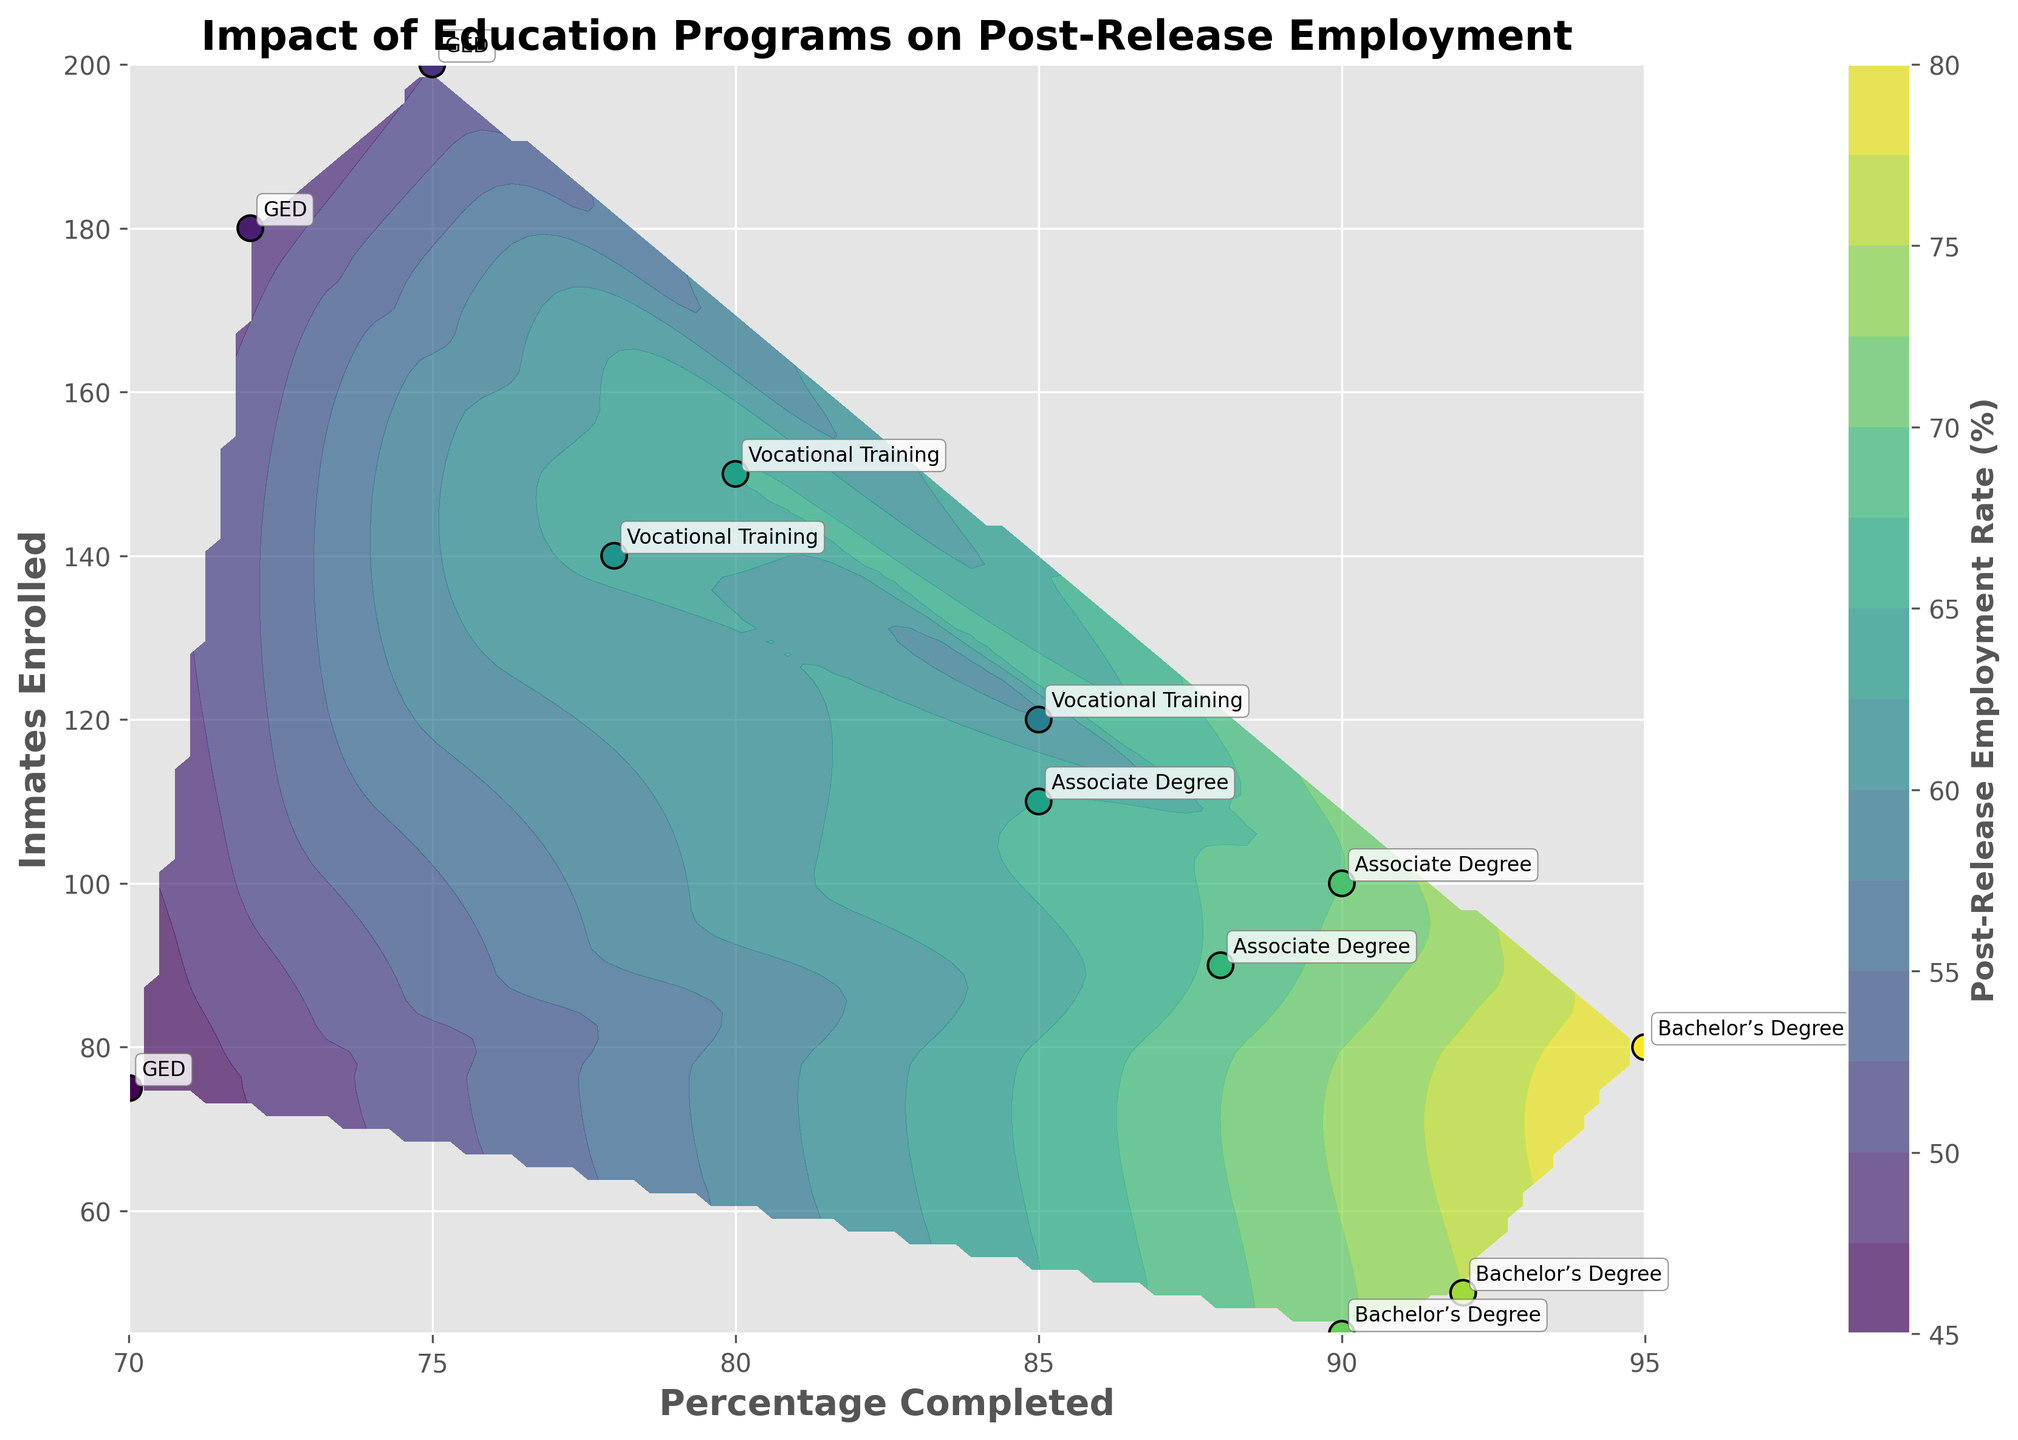What is the title of the figure? The title of the figure is usually located at the top, and it summarises the central theme of the plot. This plot's title is "Impact of Education Programs on Post-Release Employment".
Answer: Impact of Education Programs on Post-Release Employment What does the color bar represent and where is it located? The color bar is usually located beside the main plot and it indicates the magnitude of a variable. In this figure, the color bar represents the 'Post-Release Employment Rate (%)'.
Answer: Post-Release Employment Rate (%) How many inmates enrolled in the Bachelor’s Degree program at Attica Correctional Facility? Each data point on the plot is labeled with the education program. We locate the point corresponding to the Bachelor's Degree at Attica Correctional Facility on the plot and check the y-axis value for the number of inmates enrolled.
Answer: 45 Which education program had the highest post-release employment rate and at which facility? The color of the scatter points corresponds to the post-release employment rate. The darkest point (higher value) represents the highest rate. By looking at the plot, the Bachelor’s Degree at Marion Correctional Institution had the highest post-release employment rate.
Answer: Bachelor’s Degree at Marion Correctional Institution Which education program has the smallest percentage completed? By inspecting the x-axis, which indicates the 'Percentage Completed', we locate the left-most point on the plot. The GED program at Attica Correctional Facility has the smallest percentage completed.
Answer: GED at Attica Correctional Facility What is the common pattern between the completion percentage and the post-release employment rate? To discern this pattern, we observe the trend of the contour lines and scatter points. Higher percentage completions (right side of the plot) generally show higher employment rates (darker colors).
Answer: Higher completion percentages correspond to higher post-release employment rates Are there any facilities where multiple education programs are offered? If so, name them. By examining the annotations and points in the plot, we can see that some facilities have multiple programs. Folsom State Prison and Marion Correctional Institution offer multiple programs.
Answer: Folsom State Prison and Marion Correctional Institution Compare the post-release employment rate of the Vocational Training program at Folsom State Prison to the GED program at the same location. The color and value indicating post-release employment rates can be used for comparison. The Vocational Training program has a higher employment rate than the GED program at Folsom State Prison.
Answer: Vocational Training is higher Evaluate the relationship between the number of inmates enrolled and the post-release employment rate for the Associate Degree program at different facilities. Checking the scatter points labeled 'Associate Degree' and relating their y-axis position to color (employment rate), we see Marion Correctional Institution and San Quentin State Prison. Marion has a higher post-release employment rate but fewer inmates enrolled compared to San Quentin.
Answer: Fewer enrolled inmates correlated with a higher employment rate at Marion 